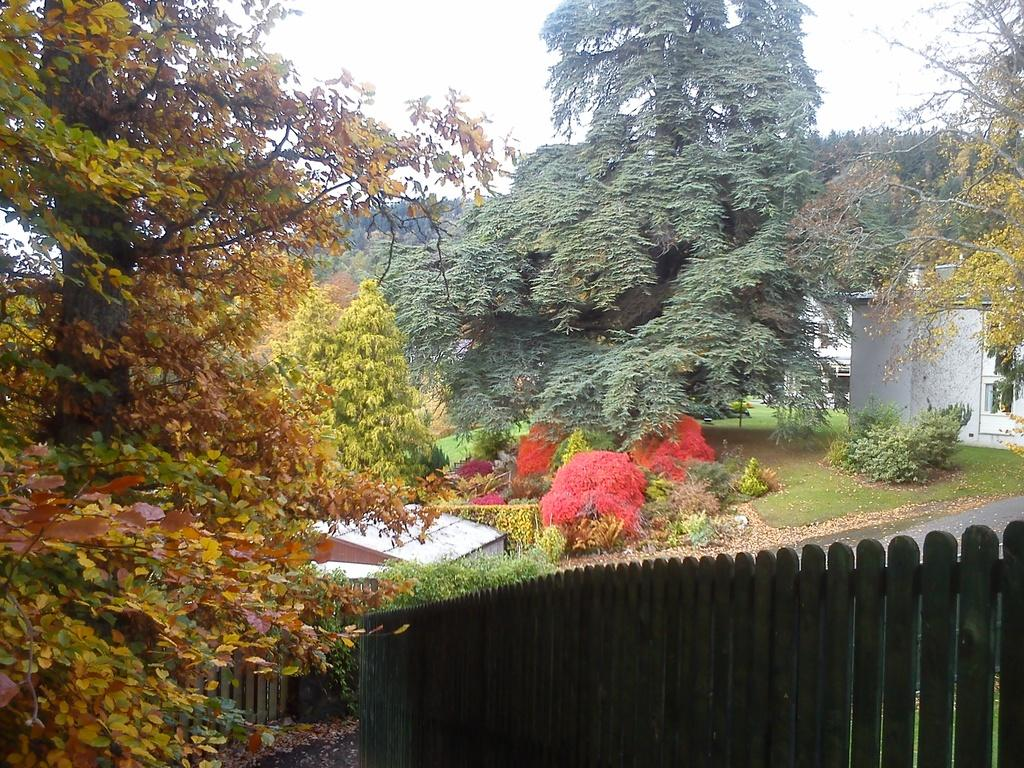What can be seen in the foreground of the image? There is a wooden railing and trees in the foreground of the image. What is visible in the background of the image? There are trees, a shelter, buildings, grass, a road, and the sky visible in the background of the image. What type of stew is being served at the shelter in the image? There is no indication of any stew being served in the image; the shelter is simply a structure visible in the background. How many birds are perched on the wooden railing in the image? There are no birds present on the wooden railing in the image. 